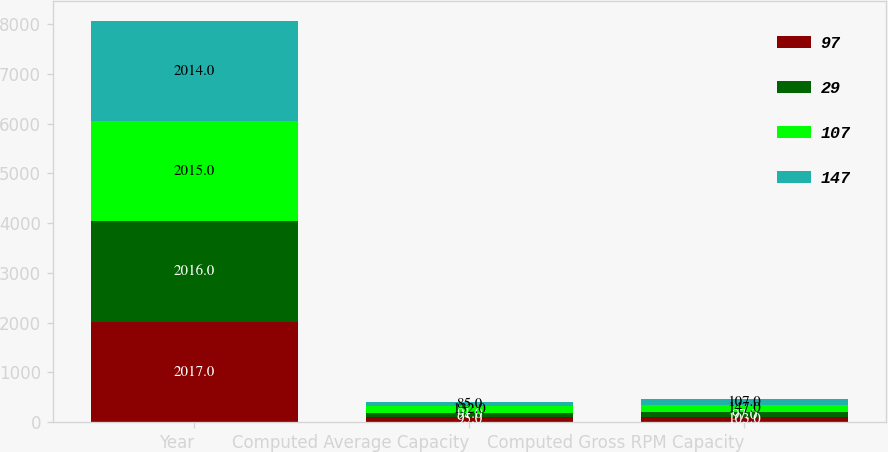Convert chart to OTSL. <chart><loc_0><loc_0><loc_500><loc_500><stacked_bar_chart><ecel><fcel>Year<fcel>Computed Average Capacity<fcel>Computed Gross RPM Capacity<nl><fcel>97<fcel>2017<fcel>95<fcel>103<nl><fcel>29<fcel>2016<fcel>91<fcel>97<nl><fcel>107<fcel>2015<fcel>132<fcel>147<nl><fcel>147<fcel>2014<fcel>85<fcel>107<nl></chart> 